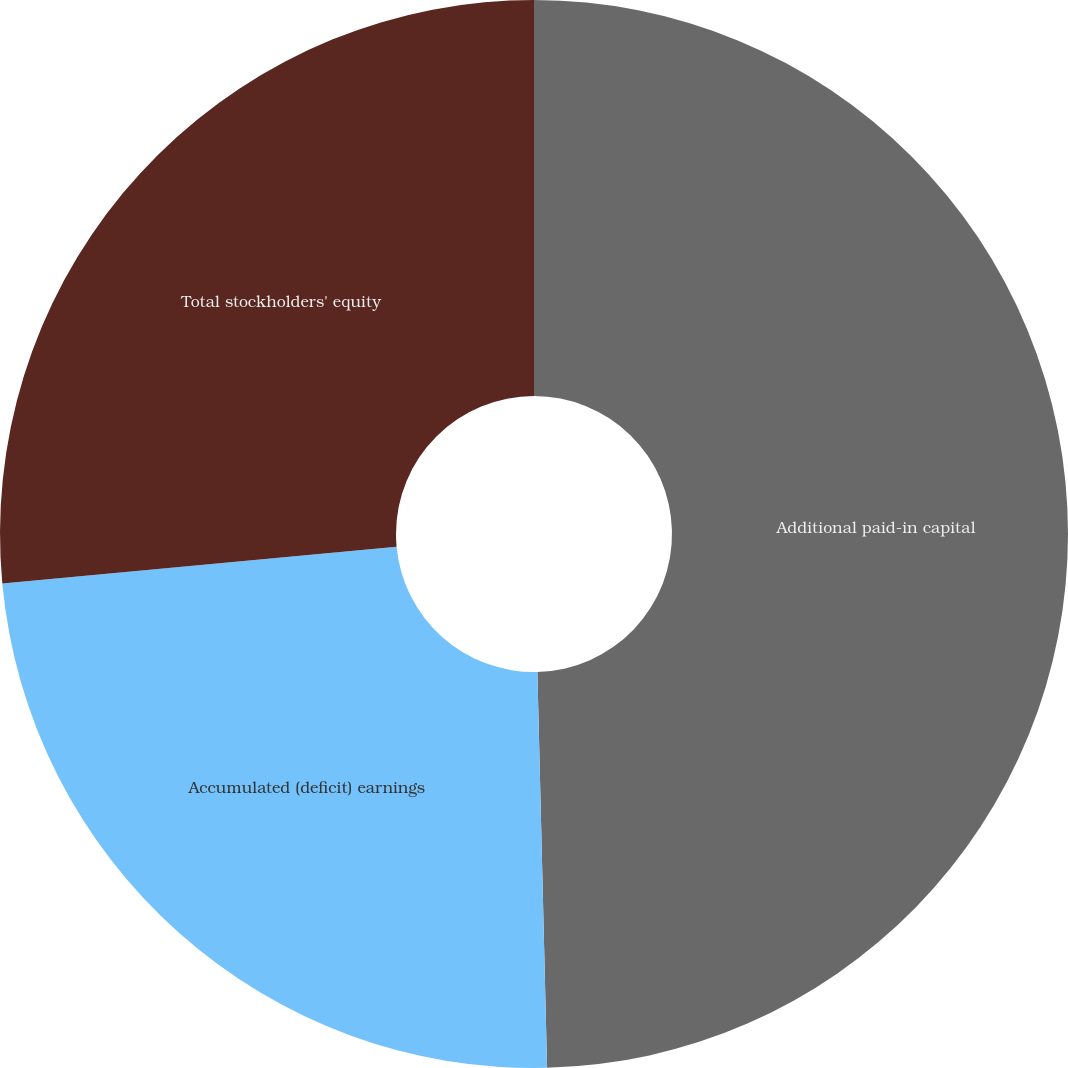Convert chart. <chart><loc_0><loc_0><loc_500><loc_500><pie_chart><fcel>Additional paid-in capital<fcel>Accumulated (deficit) earnings<fcel>Total stockholders' equity<nl><fcel>49.61%<fcel>23.91%<fcel>26.48%<nl></chart> 